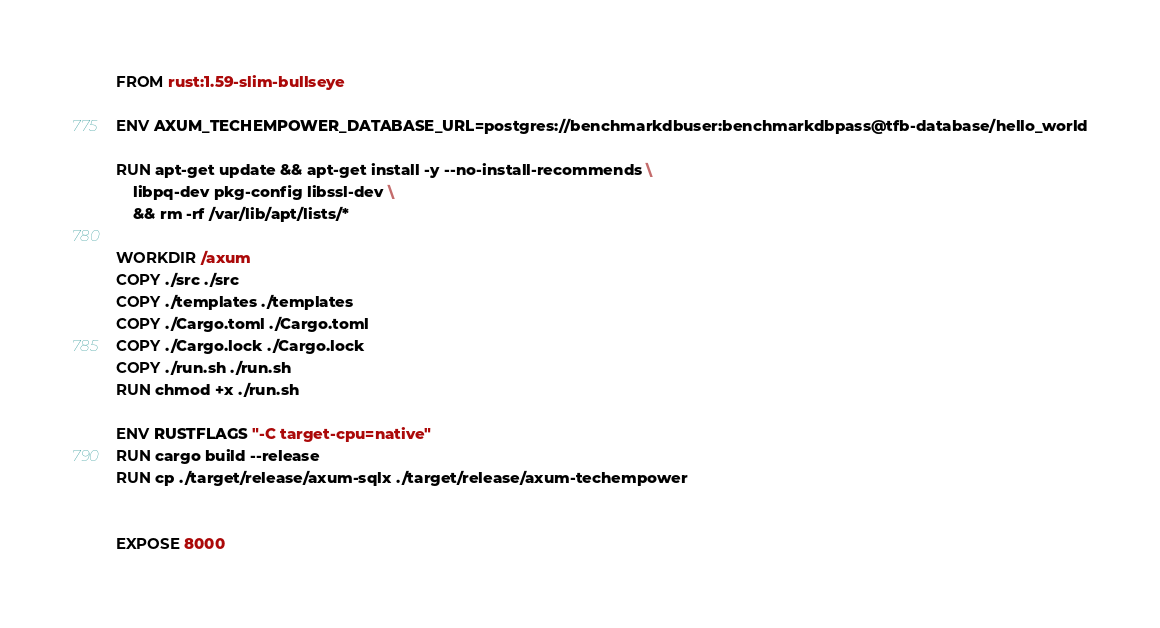<code> <loc_0><loc_0><loc_500><loc_500><_Dockerfile_>FROM rust:1.59-slim-bullseye

ENV AXUM_TECHEMPOWER_DATABASE_URL=postgres://benchmarkdbuser:benchmarkdbpass@tfb-database/hello_world

RUN apt-get update && apt-get install -y --no-install-recommends \
    libpq-dev pkg-config libssl-dev \
    && rm -rf /var/lib/apt/lists/*

WORKDIR /axum
COPY ./src ./src
COPY ./templates ./templates
COPY ./Cargo.toml ./Cargo.toml
COPY ./Cargo.lock ./Cargo.lock
COPY ./run.sh ./run.sh
RUN chmod +x ./run.sh

ENV RUSTFLAGS "-C target-cpu=native"
RUN cargo build --release
RUN cp ./target/release/axum-sqlx ./target/release/axum-techempower


EXPOSE 8000
</code> 